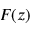Convert formula to latex. <formula><loc_0><loc_0><loc_500><loc_500>F ( z )</formula> 